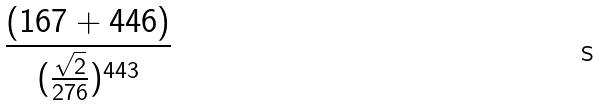Convert formula to latex. <formula><loc_0><loc_0><loc_500><loc_500>\frac { ( 1 6 7 + 4 4 6 ) } { ( \frac { \sqrt { 2 } } { 2 7 6 } ) ^ { 4 4 3 } }</formula> 